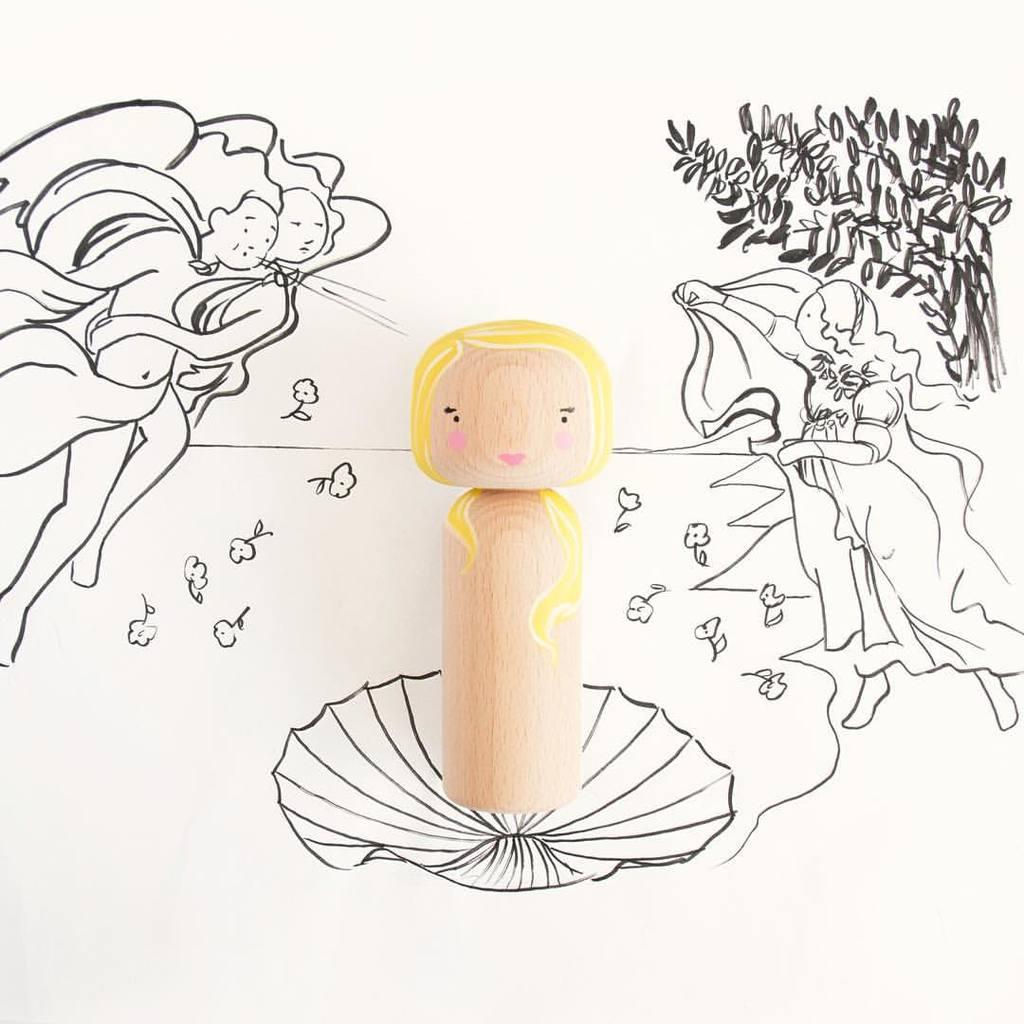What type of doll is in the image? There is a wooden doll in the image. Where is the wooden doll placed? The wooden doll is placed on a paper. What is depicted on the paper? The paper contains a painting of women. What other elements are included in the painting? The painting includes flowers and plants. What type of songs are being sung by the doll in the image? The wooden doll is not singing any songs in the image; it is a static object. 